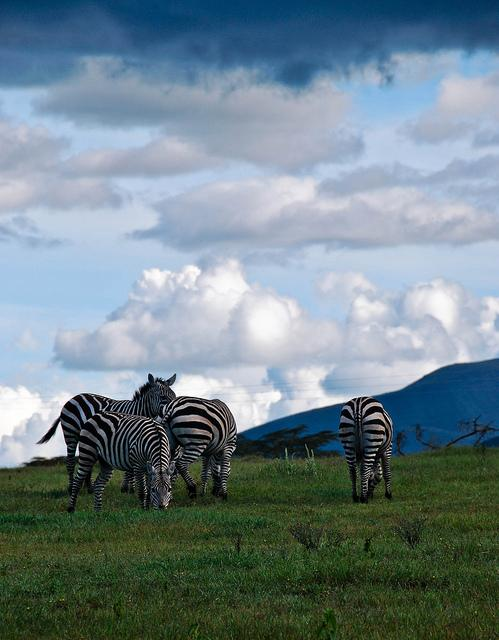How many zebras are grazing in the field before the mountain? Please explain your reasoning. four. There are four of them. 